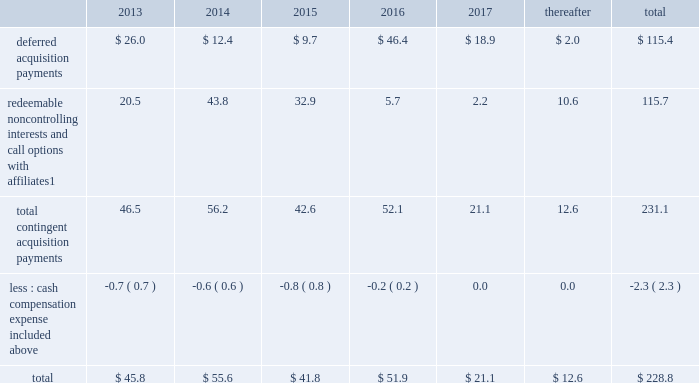Notes to consolidated financial statements 2013 ( continued ) ( amounts in millions , except per share amounts ) guarantees we have guaranteed certain obligations of our subsidiaries relating principally to operating leases and credit facilities of certain subsidiaries .
The amount of parent company guarantees on lease obligations was $ 410.3 and $ 385.1 as of december 31 , 2012 and 2011 , respectively , and the amount of parent company guarantees primarily relating to credit facilities was $ 283.4 and $ 327.5 as of december 31 , 2012 and 2011 , respectively .
In the event of non-payment by the applicable subsidiary of the obligations covered by a guarantee , we would be obligated to pay the amounts covered by that guarantee .
As of december 31 , 2012 , there were no material assets pledged as security for such parent company guarantees .
Contingent acquisition obligations the table details the estimated future contingent acquisition obligations payable in cash as of december 31 .
1 we have entered into certain acquisitions that contain both redeemable noncontrolling interests and call options with similar terms and conditions .
We have certain redeemable noncontrolling interests that are exercisable at the discretion of the noncontrolling equity owners as of december 31 , 2012 .
These estimated payments of $ 16.4 are included within the total payments expected to be made in 2013 , and will continue to be carried forward into 2014 or beyond until exercised or expired .
Redeemable noncontrolling interests are included in the table at current exercise price payable in cash , not at applicable redemption value in accordance with the authoritative guidance for classification and measurement of redeemable securities .
The estimated amounts listed would be paid in the event of exercise at the earliest exercise date .
See note 6 for further information relating to the payment structure of our acquisitions .
All payments are contingent upon achieving projected operating performance targets and satisfying other conditions specified in the related agreements and are subject to revisions as the earn-out periods progress .
Legal matters we are involved in various legal proceedings , and subject to investigations , inspections , audits , inquiries and similar actions by governmental authorities , arising in the normal course of business .
We evaluate all cases each reporting period and record liabilities for losses from legal proceedings when we determine that it is probable that the outcome in a legal proceeding will be unfavorable and the amount , or potential range , of loss can be reasonably estimated .
In certain cases , we cannot reasonably estimate the potential loss because , for example , the litigation is in its early stages .
While any outcome related to litigation or such governmental proceedings in which we are involved cannot be predicted with certainty , management believes that the outcome of these matters , individually and in the aggregate , will not have a material adverse effect on our financial condition , results of operations or cash flows .
Note 15 : recent accounting standards impairment of indefinite-lived intangible assets in july 2012 , the financial accounting standards board ( 201cfasb 201d ) issued amended guidance to simplify impairment testing of indefinite-lived intangible assets other than goodwill .
The amended guidance permits an entity to first assess qualitative factors to determine whether it is 201cmore likely than not 201d that the indefinite-lived intangible asset is impaired .
If , after assessing qualitative factors , an entity concludes that it is not 201cmore likely than not 201d that the indefinite-lived intangible .
In 2012 what was the ratio of the parent company guarantees on lease obligations to the credit facilities? 
Rationale: in 2012 the parent company guaranteed $ 1.45 on lease obligations per $ 1 of credit facilities
Computations: (410.3 / 283.4)
Answer: 1.44778. 